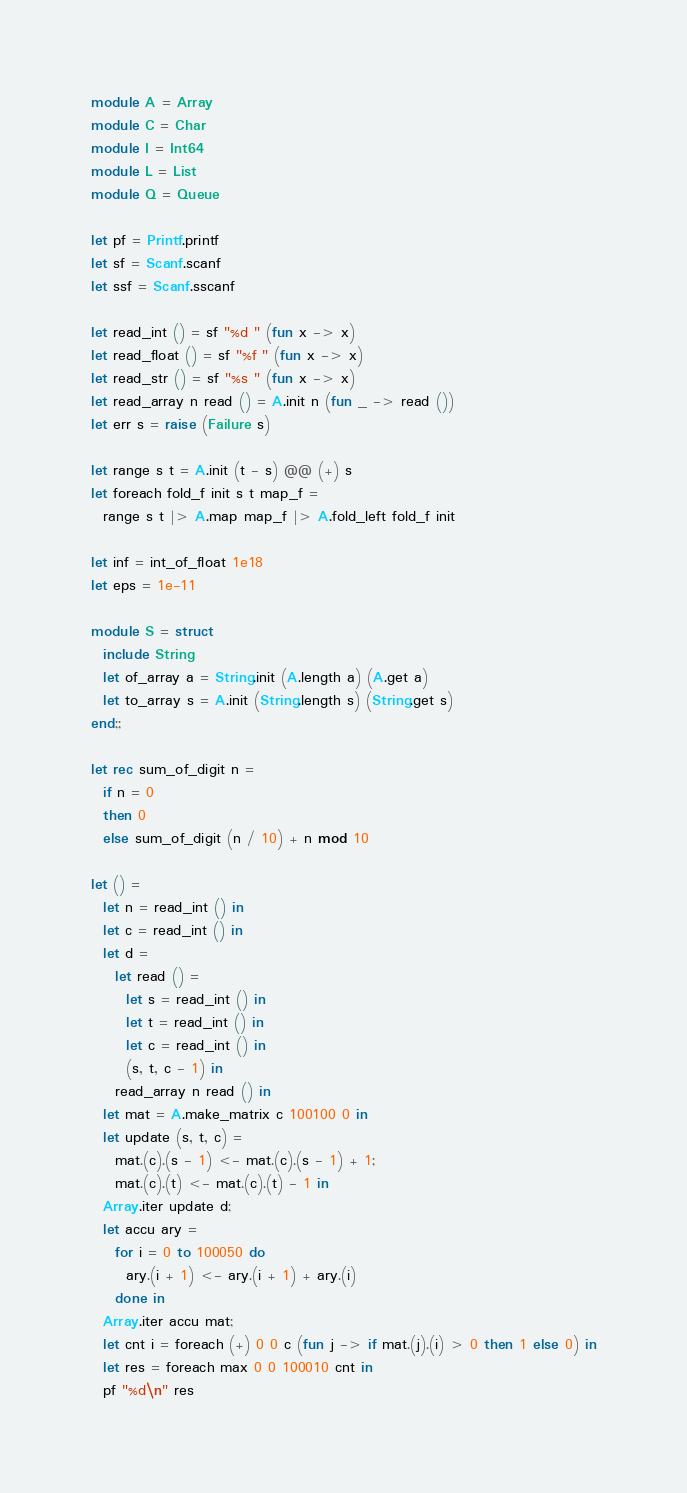Convert code to text. <code><loc_0><loc_0><loc_500><loc_500><_OCaml_>module A = Array
module C = Char
module I = Int64
module L = List
module Q = Queue

let pf = Printf.printf
let sf = Scanf.scanf
let ssf = Scanf.sscanf

let read_int () = sf "%d " (fun x -> x)
let read_float () = sf "%f " (fun x -> x)
let read_str () = sf "%s " (fun x -> x)
let read_array n read () = A.init n (fun _ -> read ())
let err s = raise (Failure s)

let range s t = A.init (t - s) @@ (+) s
let foreach fold_f init s t map_f =
  range s t |> A.map map_f |> A.fold_left fold_f init

let inf = int_of_float 1e18
let eps = 1e-11

module S = struct
  include String
  let of_array a = String.init (A.length a) (A.get a)
  let to_array s = A.init (String.length s) (String.get s)
end;;

let rec sum_of_digit n =
  if n = 0
  then 0
  else sum_of_digit (n / 10) + n mod 10

let () =
  let n = read_int () in
  let c = read_int () in
  let d =
    let read () =
      let s = read_int () in
      let t = read_int () in
      let c = read_int () in
      (s, t, c - 1) in
    read_array n read () in
  let mat = A.make_matrix c 100100 0 in
  let update (s, t, c) =
    mat.(c).(s - 1) <- mat.(c).(s - 1) + 1;
    mat.(c).(t) <- mat.(c).(t) - 1 in
  Array.iter update d;
  let accu ary =
    for i = 0 to 100050 do
      ary.(i + 1) <- ary.(i + 1) + ary.(i)
    done in
  Array.iter accu mat;
  let cnt i = foreach (+) 0 0 c (fun j -> if mat.(j).(i) > 0 then 1 else 0) in
  let res = foreach max 0 0 100010 cnt in
  pf "%d\n" res
</code> 